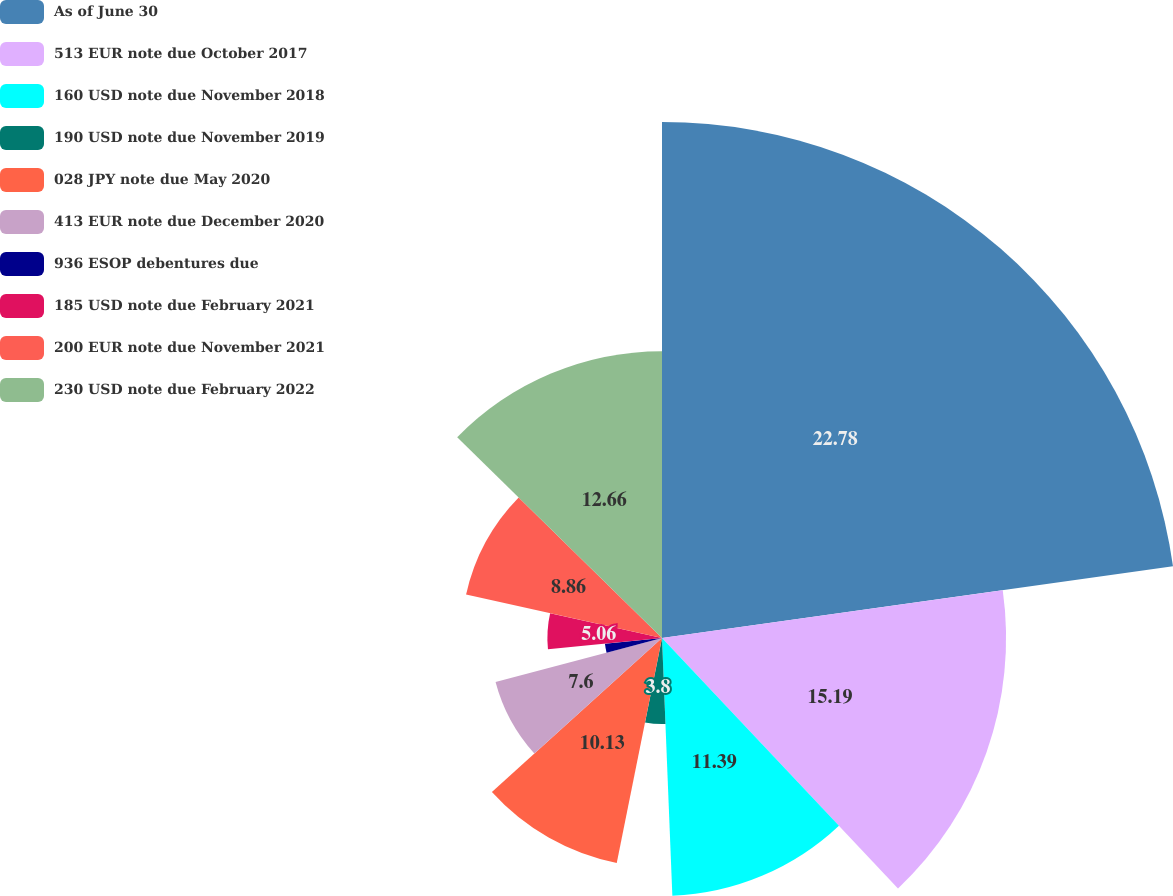Convert chart. <chart><loc_0><loc_0><loc_500><loc_500><pie_chart><fcel>As of June 30<fcel>513 EUR note due October 2017<fcel>160 USD note due November 2018<fcel>190 USD note due November 2019<fcel>028 JPY note due May 2020<fcel>413 EUR note due December 2020<fcel>936 ESOP debentures due<fcel>185 USD note due February 2021<fcel>200 EUR note due November 2021<fcel>230 USD note due February 2022<nl><fcel>22.78%<fcel>15.19%<fcel>11.39%<fcel>3.8%<fcel>10.13%<fcel>7.6%<fcel>2.53%<fcel>5.06%<fcel>8.86%<fcel>12.66%<nl></chart> 